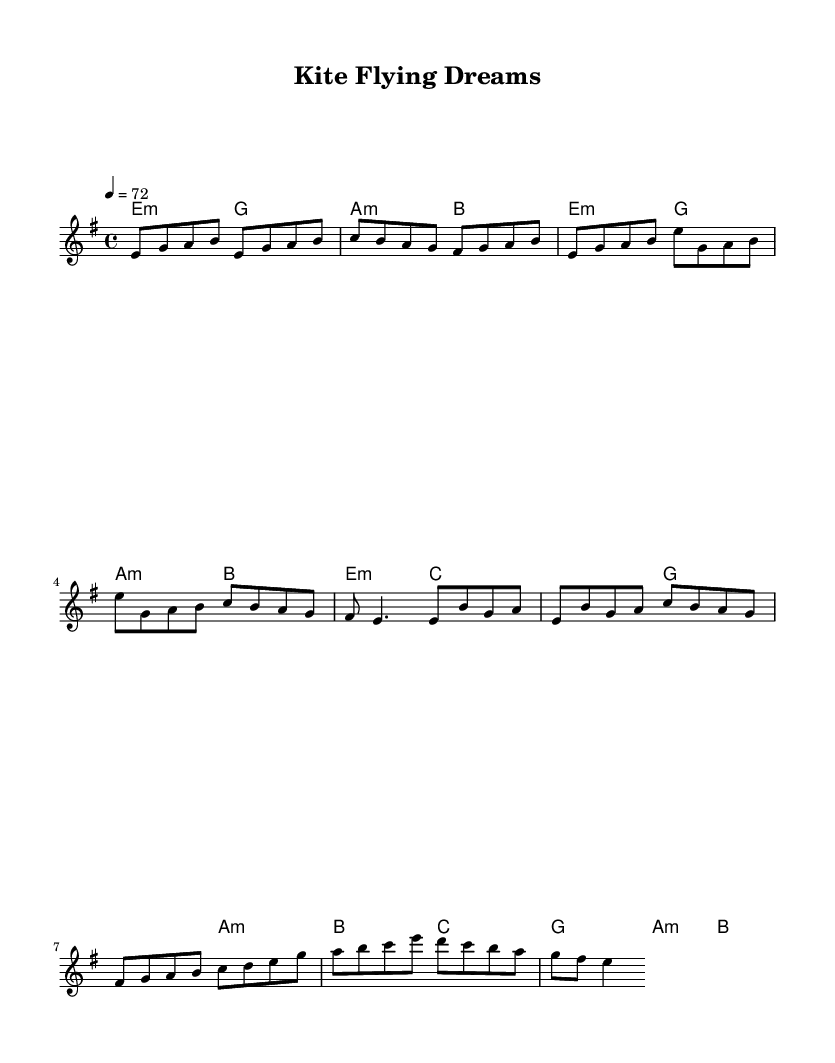What is the time signature of this music? The time signature, located at the beginning of the staff, is specified as 4/4. This means there are 4 beats in each measure and the quarter note receives one beat.
Answer: 4/4 What is the key signature of this music? The key signature is indicated at the start of the piece, showing one sharp. It is in E minor, which is the relative minor of G major.
Answer: E minor What is the tempo marking of this music? The tempo, shown at the beginning as a quarter note equals 72, indicates how fast the music should be played. This means there are 72 quarter-note beats per minute.
Answer: 72 How many measures are there in the chorus? The chorus section consists of 4 measures, where the melody reaches a climactic point, reflecting the emotional core of the song.
Answer: 4 What chords are played during the bridge? The bridge uses the chords C major and G major as indicated in the harmonies section, providing a change in texture and emotion in the piece.
Answer: C and G Is this piece a ballad? This piece is a ballad because it evokes a nostalgic sentiment, focusing on themes of childhood friendships and simple joys, typical in metal ballads.
Answer: Yes 